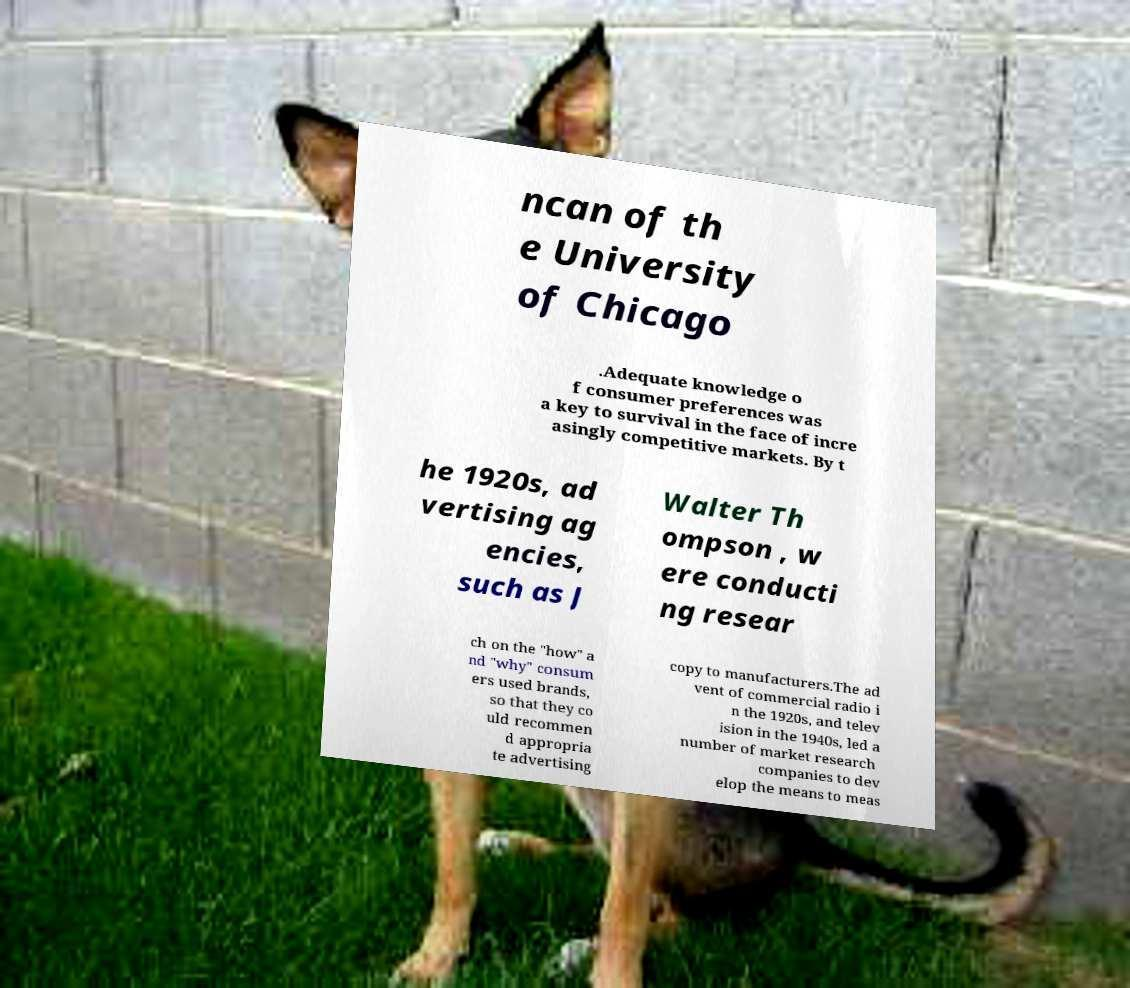Can you accurately transcribe the text from the provided image for me? ncan of th e University of Chicago .Adequate knowledge o f consumer preferences was a key to survival in the face of incre asingly competitive markets. By t he 1920s, ad vertising ag encies, such as J Walter Th ompson , w ere conducti ng resear ch on the "how" a nd "why" consum ers used brands, so that they co uld recommen d appropria te advertising copy to manufacturers.The ad vent of commercial radio i n the 1920s, and telev ision in the 1940s, led a number of market research companies to dev elop the means to meas 